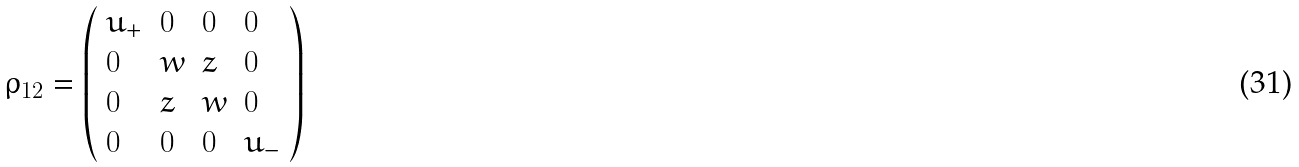Convert formula to latex. <formula><loc_0><loc_0><loc_500><loc_500>\rho _ { 1 2 } = \left ( \begin{array} { l l l l } u _ { + } & 0 & 0 & 0 \\ 0 & w & z & 0 \\ 0 & z & w & 0 \\ 0 & 0 & 0 & u _ { - } \end{array} \right )</formula> 